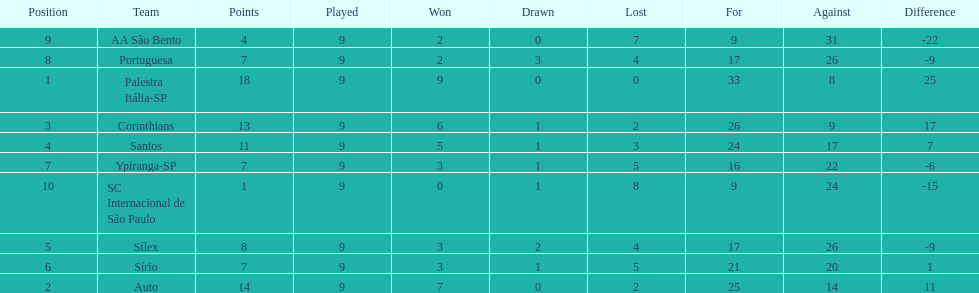How many teams had more points than silex? 4. 